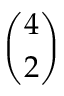Convert formula to latex. <formula><loc_0><loc_0><loc_500><loc_500>\binom { 4 } { 2 }</formula> 